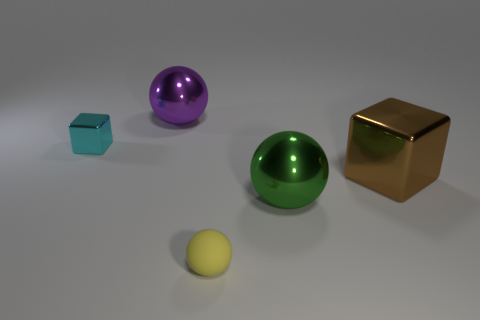How big is the cube that is left of the object behind the tiny object that is behind the matte thing?
Offer a terse response. Small. There is a large thing that is behind the metallic cube to the right of the tiny yellow rubber object; what is its material?
Your response must be concise. Metal. Is there a cyan rubber object of the same shape as the brown metal object?
Your response must be concise. No. What is the shape of the large brown metallic thing?
Offer a terse response. Cube. What material is the sphere in front of the large sphere that is in front of the big shiny sphere behind the green metal sphere?
Provide a short and direct response. Rubber. Is the number of big metallic blocks to the right of the green object greater than the number of big shiny balls?
Provide a succinct answer. No. There is a block that is the same size as the rubber object; what is its material?
Your answer should be compact. Metal. Is there a sphere of the same size as the rubber object?
Your answer should be very brief. No. There is a shiny sphere right of the yellow matte object; what size is it?
Provide a succinct answer. Large. How big is the cyan object?
Your answer should be very brief. Small. 